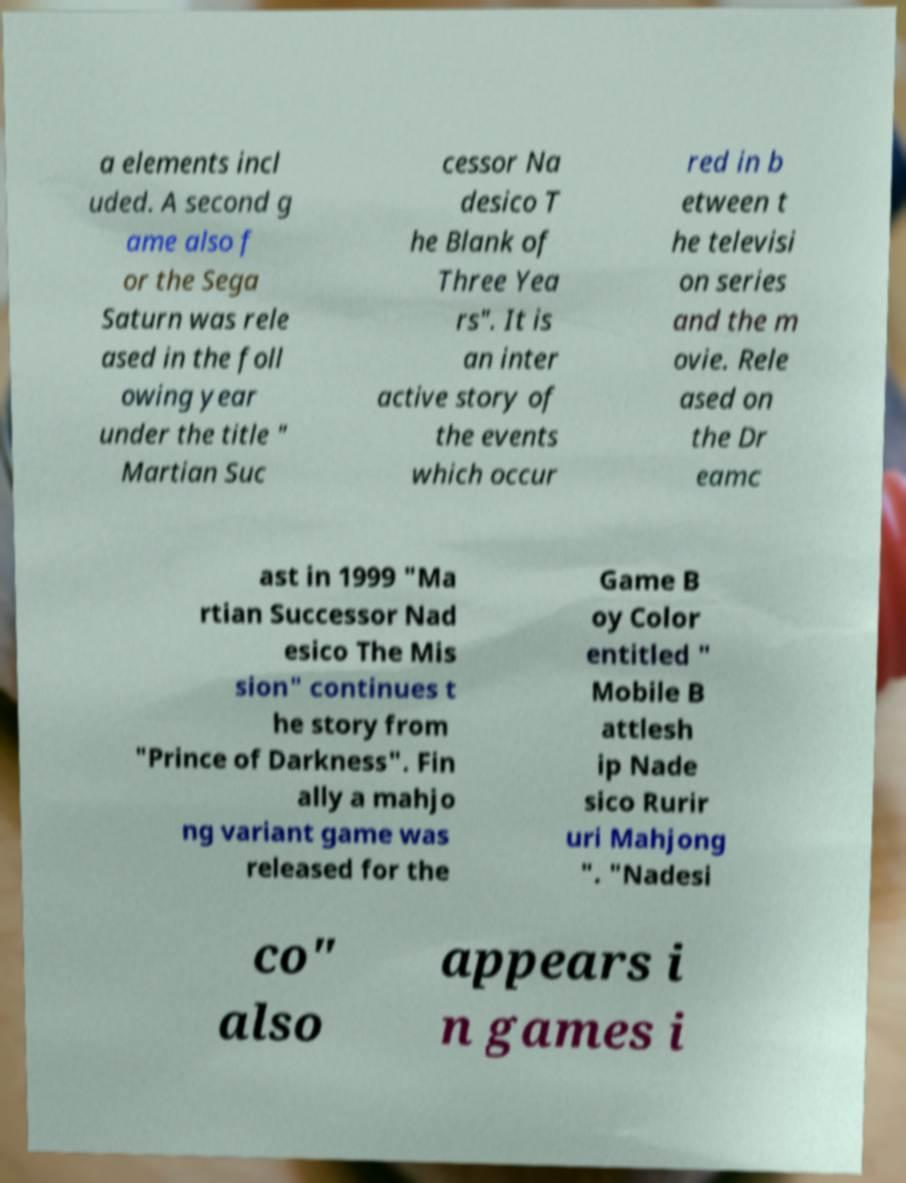For documentation purposes, I need the text within this image transcribed. Could you provide that? a elements incl uded. A second g ame also f or the Sega Saturn was rele ased in the foll owing year under the title " Martian Suc cessor Na desico T he Blank of Three Yea rs". It is an inter active story of the events which occur red in b etween t he televisi on series and the m ovie. Rele ased on the Dr eamc ast in 1999 "Ma rtian Successor Nad esico The Mis sion" continues t he story from "Prince of Darkness". Fin ally a mahjo ng variant game was released for the Game B oy Color entitled " Mobile B attlesh ip Nade sico Rurir uri Mahjong ". "Nadesi co" also appears i n games i 